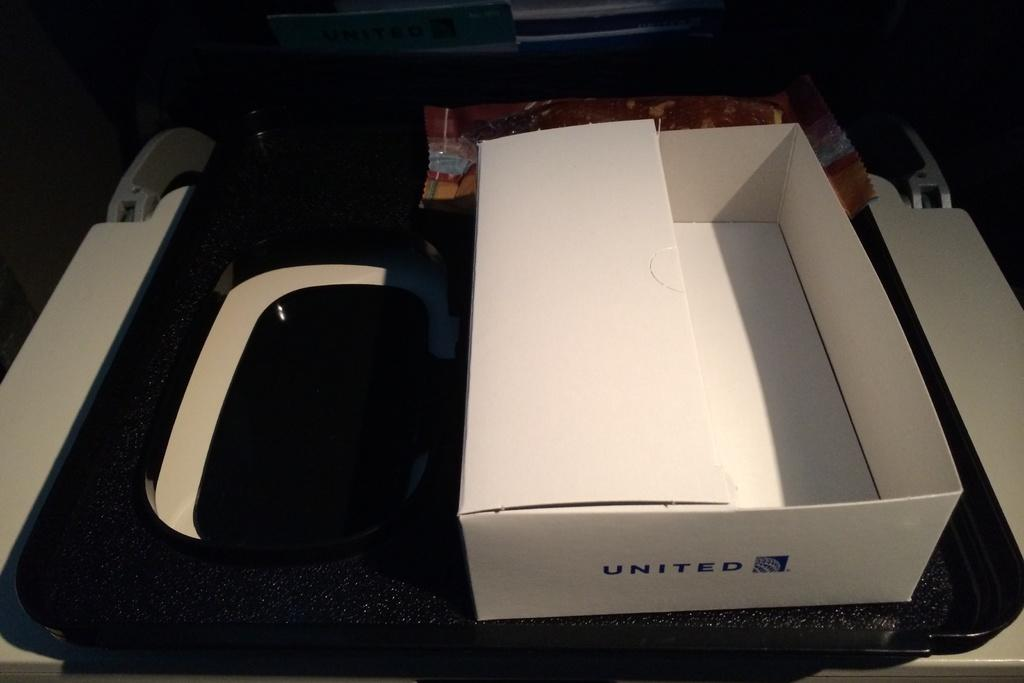<image>
Create a compact narrative representing the image presented. white box with United printed on it in blue. 